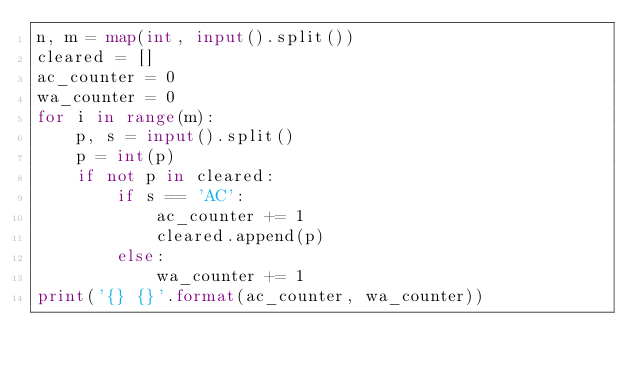Convert code to text. <code><loc_0><loc_0><loc_500><loc_500><_Python_>n, m = map(int, input().split())
cleared = []
ac_counter = 0
wa_counter = 0
for i in range(m):
    p, s = input().split()
    p = int(p)
    if not p in cleared:
        if s == 'AC':
            ac_counter += 1
            cleared.append(p)
        else:
            wa_counter += 1
print('{} {}'.format(ac_counter, wa_counter))</code> 